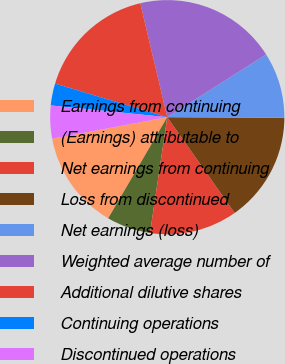Convert chart. <chart><loc_0><loc_0><loc_500><loc_500><pie_chart><fcel>Earnings from continuing<fcel>(Earnings) attributable to<fcel>Net earnings from continuing<fcel>Loss from discontinued<fcel>Net earnings (loss)<fcel>Weighted average number of<fcel>Additional dilutive shares<fcel>Continuing operations<fcel>Discontinued operations<nl><fcel>13.64%<fcel>6.06%<fcel>12.12%<fcel>15.15%<fcel>9.09%<fcel>19.7%<fcel>16.67%<fcel>3.03%<fcel>4.55%<nl></chart> 